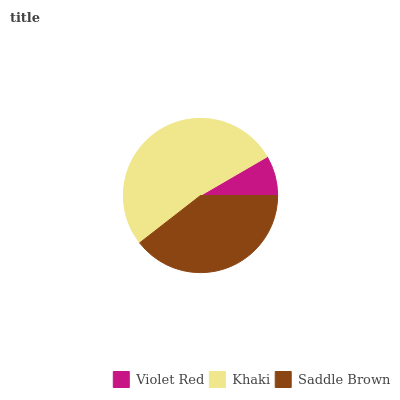Is Violet Red the minimum?
Answer yes or no. Yes. Is Khaki the maximum?
Answer yes or no. Yes. Is Saddle Brown the minimum?
Answer yes or no. No. Is Saddle Brown the maximum?
Answer yes or no. No. Is Khaki greater than Saddle Brown?
Answer yes or no. Yes. Is Saddle Brown less than Khaki?
Answer yes or no. Yes. Is Saddle Brown greater than Khaki?
Answer yes or no. No. Is Khaki less than Saddle Brown?
Answer yes or no. No. Is Saddle Brown the high median?
Answer yes or no. Yes. Is Saddle Brown the low median?
Answer yes or no. Yes. Is Khaki the high median?
Answer yes or no. No. Is Khaki the low median?
Answer yes or no. No. 